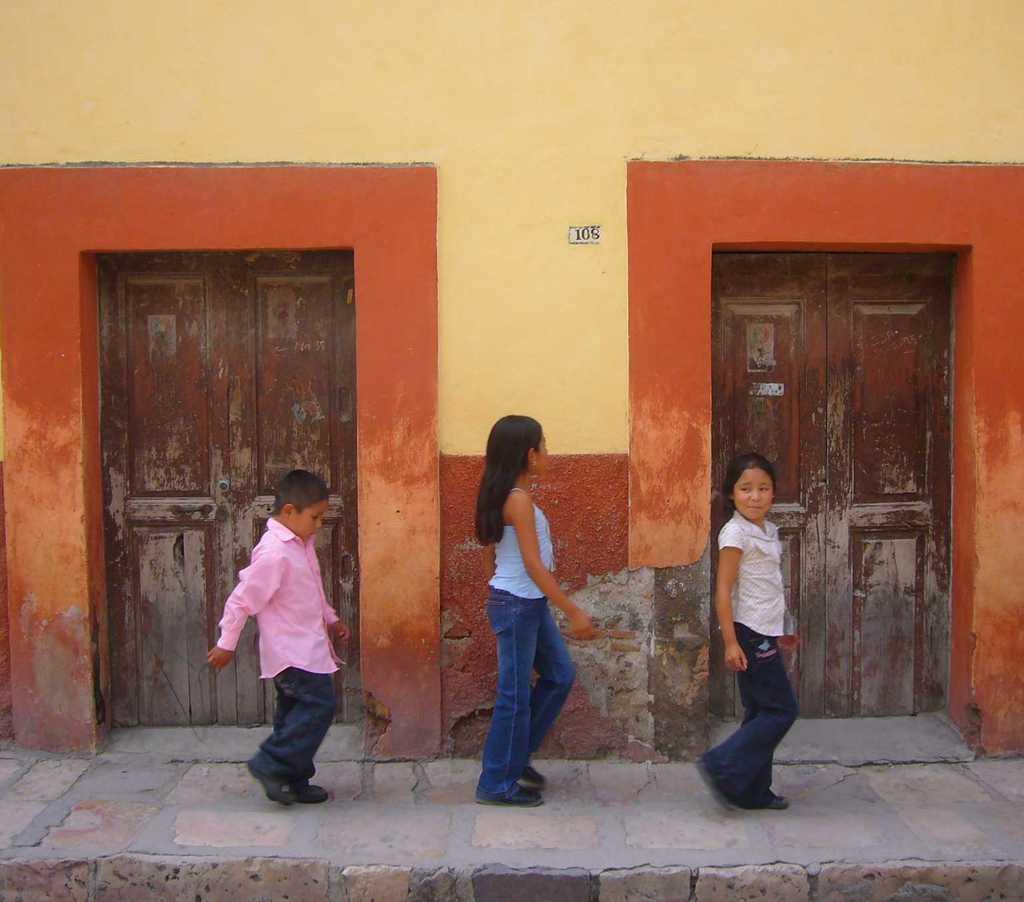Describe this image in one or two sentences. In the image there are three kids walking on the footpath in front of the building with two doors on either side. 